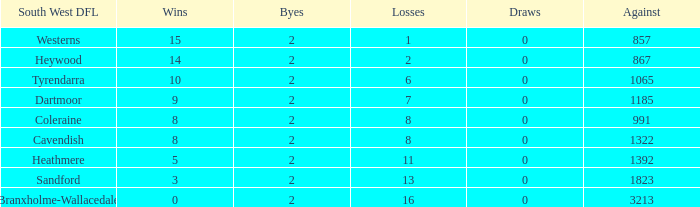In the south west dfl of tyrendarra, how many draws are there with fewer than 10 wins? None. 